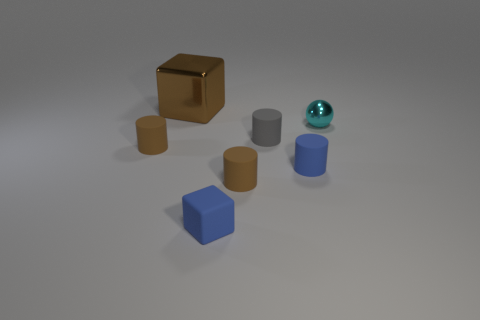Subtract 1 cylinders. How many cylinders are left? 3 Add 2 cubes. How many objects exist? 9 Subtract all cylinders. How many objects are left? 3 Subtract all large yellow spheres. Subtract all metal blocks. How many objects are left? 6 Add 2 small spheres. How many small spheres are left? 3 Add 3 large objects. How many large objects exist? 4 Subtract 0 gray cubes. How many objects are left? 7 